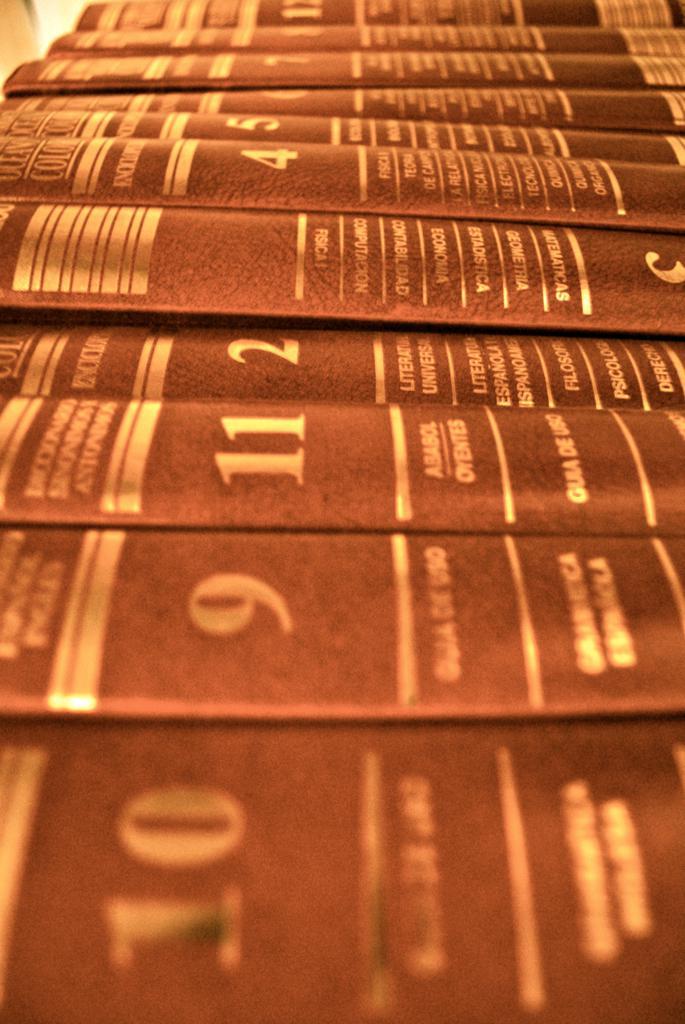What volume is second in the row?
Your answer should be compact. 9. 